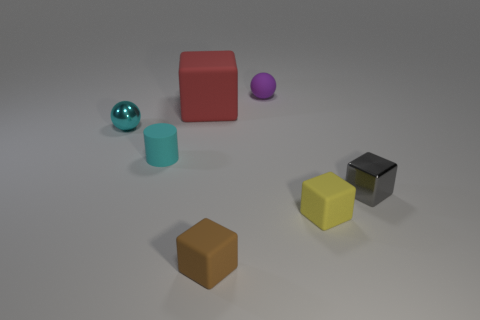Is there a gray metallic cube left of the sphere on the left side of the large red thing?
Offer a very short reply. No. Is the number of tiny yellow rubber things that are behind the yellow matte cube the same as the number of small cyan shiny balls?
Give a very brief answer. No. What number of other things are there of the same size as the red object?
Keep it short and to the point. 0. Are the ball on the right side of the brown rubber thing and the small cylinder that is on the left side of the big cube made of the same material?
Offer a very short reply. Yes. What size is the metal object that is to the right of the rubber cube that is right of the purple thing?
Offer a terse response. Small. Is there a small rubber cylinder of the same color as the large cube?
Your answer should be compact. No. Is the color of the rubber block that is behind the gray cube the same as the sphere on the left side of the big matte cube?
Your answer should be compact. No. The tiny yellow rubber thing has what shape?
Offer a terse response. Cube. There is a small gray metal block; what number of small yellow matte objects are to the left of it?
Your response must be concise. 1. How many small cyan balls are made of the same material as the tiny purple sphere?
Ensure brevity in your answer.  0. 